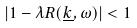Convert formula to latex. <formula><loc_0><loc_0><loc_500><loc_500>| 1 - \lambda R ( \underline { k } , \omega ) | < 1</formula> 